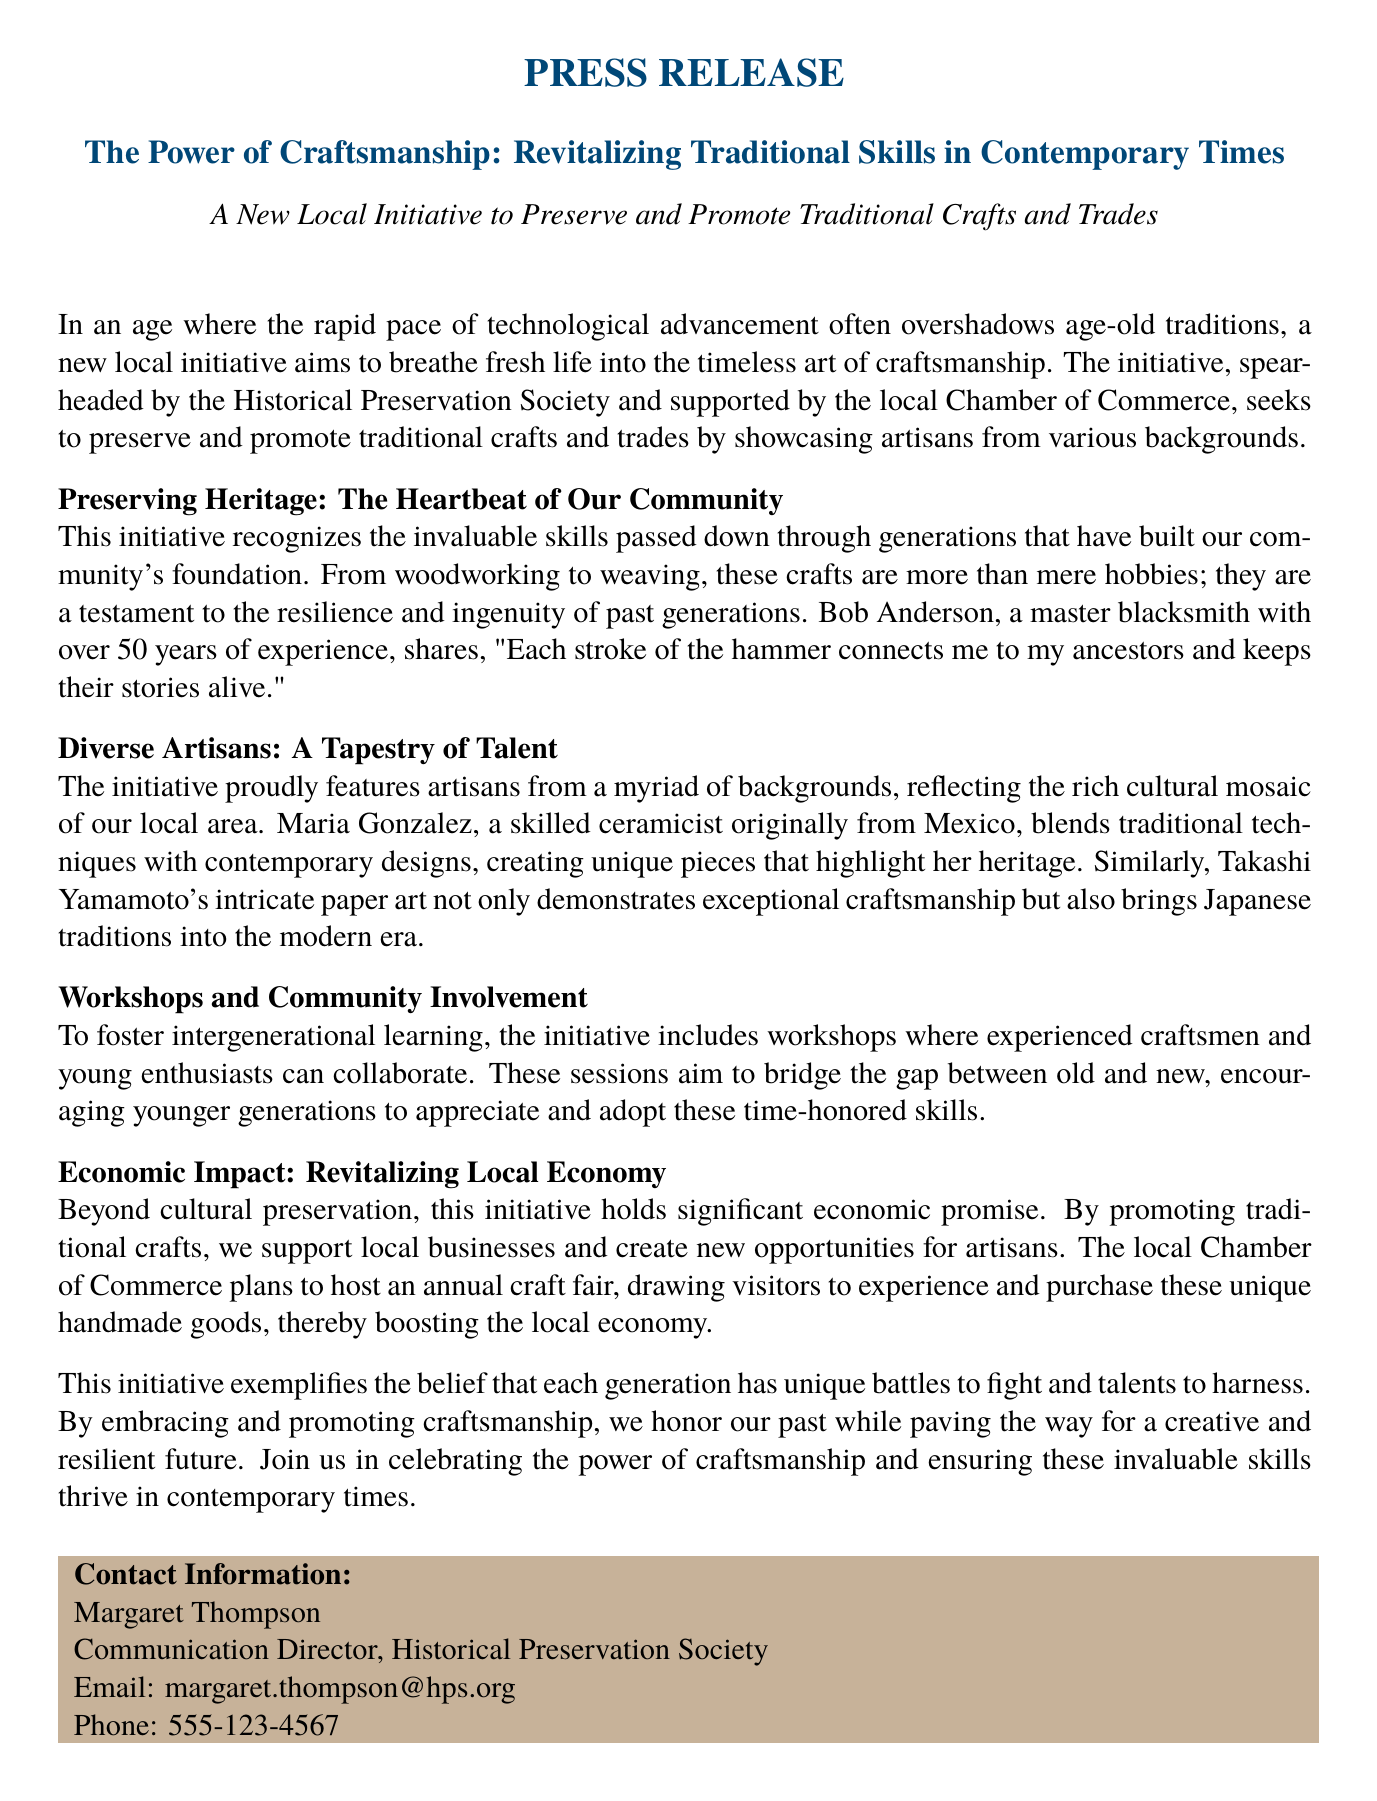What is the title of the initiative? The title of the initiative is mentioned in the press release as "The Power of Craftsmanship: Revitalizing Traditional Skills in Contemporary Times."
Answer: The Power of Craftsmanship: Revitalizing Traditional Skills in Contemporary Times Who is the master blacksmith mentioned in the document? The master blacksmith mentioned in the document is Bob Anderson.
Answer: Bob Anderson Which organization is spearheading the initiative? The organization that is spearheading the initiative is the Historical Preservation Society.
Answer: Historical Preservation Society What type of workshops does the initiative include? The initiative includes workshops for experienced craftsmen and young enthusiasts to collaborate.
Answer: Workshops for experienced craftsmen and young enthusiasts What does Maria Gonzalez create? Maria Gonzalez creates unique ceramic pieces that highlight her heritage.
Answer: Unique ceramic pieces What economic benefit does the initiative aim to achieve? The initiative aims to support local businesses and create new opportunities for artisans.
Answer: Support local businesses and create new opportunities What cultural aspect does the initiative reflect? The initiative reflects the rich cultural mosaic of the local area.
Answer: Rich cultural mosaic How many years of experience does Bob Anderson have? Bob Anderson has over 50 years of experience.
Answer: Over 50 years What event does the local Chamber of Commerce plan to host? The local Chamber of Commerce plans to host an annual craft fair.
Answer: Annual craft fair 